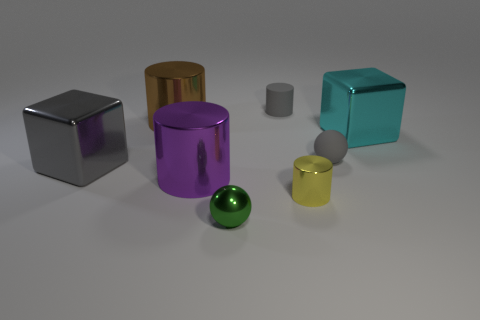Subtract all shiny cylinders. How many cylinders are left? 1 Subtract all cyan cubes. How many cubes are left? 1 Add 1 rubber balls. How many objects exist? 9 Subtract 2 cubes. How many cubes are left? 0 Subtract all gray matte spheres. Subtract all big cylinders. How many objects are left? 5 Add 4 yellow objects. How many yellow objects are left? 5 Add 5 big brown shiny things. How many big brown shiny things exist? 6 Subtract 0 cyan cylinders. How many objects are left? 8 Subtract all cyan cubes. Subtract all brown cylinders. How many cubes are left? 1 Subtract all blue balls. How many purple cubes are left? 0 